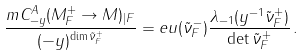<formula> <loc_0><loc_0><loc_500><loc_500>\frac { m C _ { - y } ^ { A } ( M ^ { + } _ { F } \to M ) _ { | F } } { ( - y ) ^ { \dim \tilde { \nu } ^ { + } _ { F } } } = e u ( \tilde { \nu } ^ { - } _ { F } ) \frac { \lambda _ { - 1 } ( y ^ { - 1 } \tilde { \nu } ^ { + } _ { F } ) } { \det \tilde { \nu } ^ { + } _ { F } } \, .</formula> 